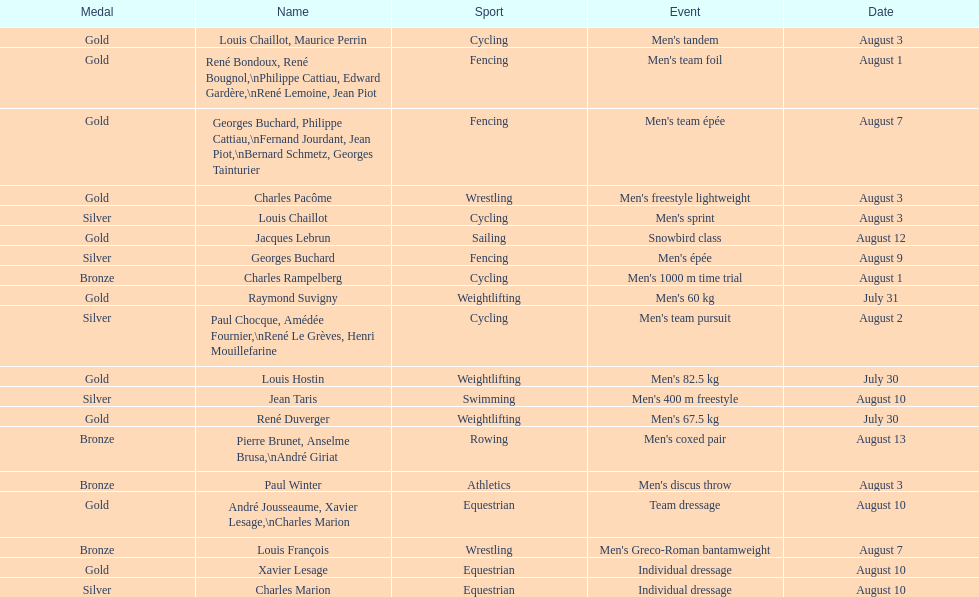How many medals were gained after august 3? 9. 